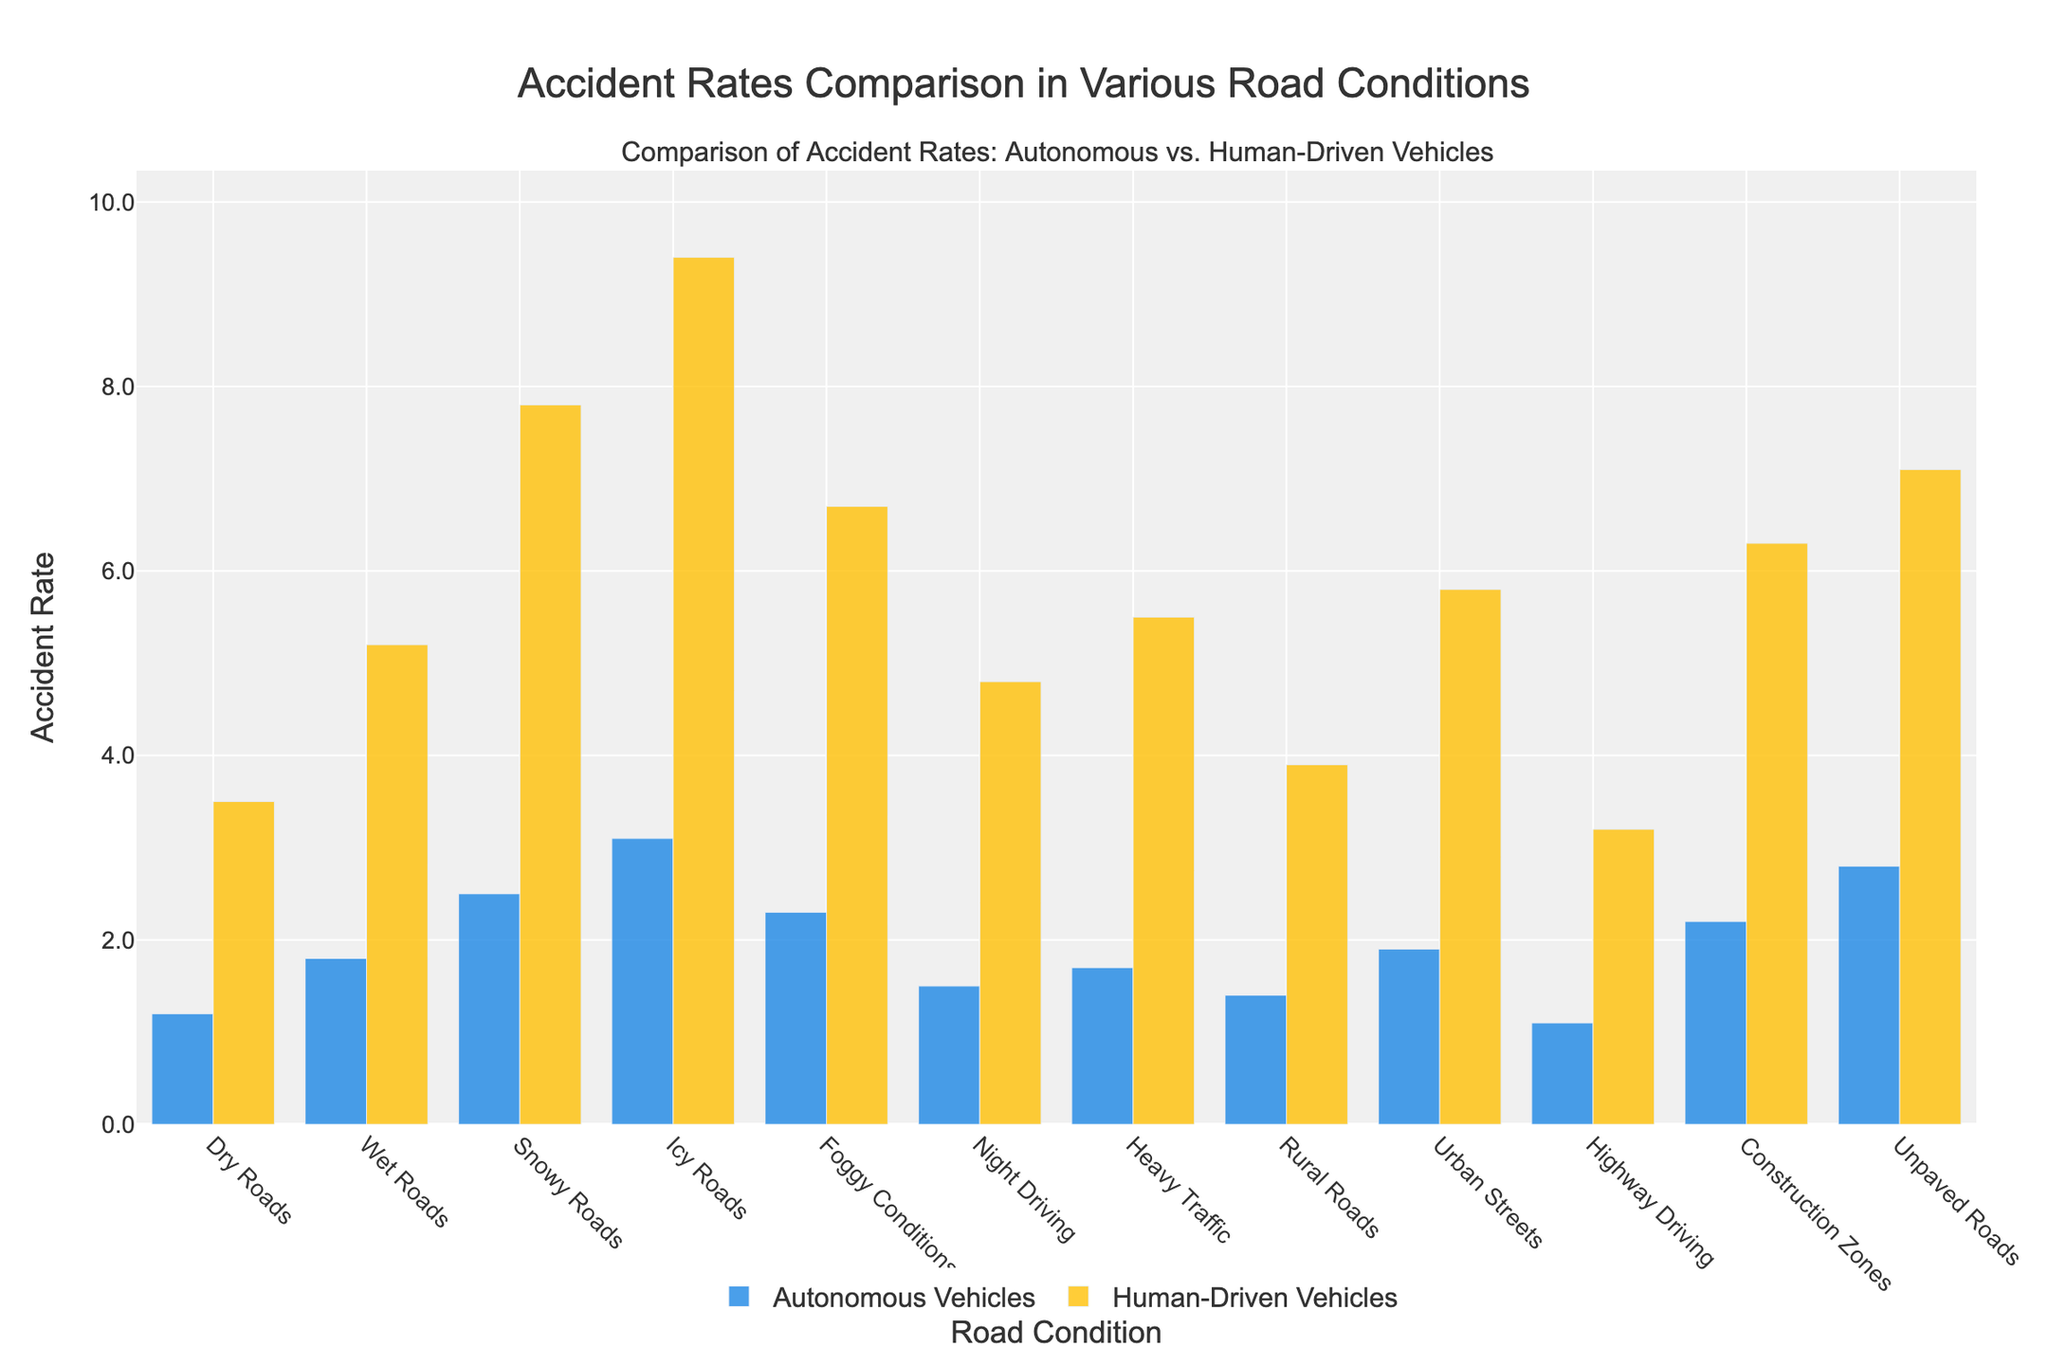What's the difference in accident rates on icy roads between autonomous and human-driven vehicles? The bars representing icy roads show that the accident rate for human-driven vehicles is 9.4, while for autonomous vehicles it is 3.1. Subtracting the autonomous rate from the human-driven rate gives 9.4 - 3.1 = 6.3.
Answer: 6.3 Which road condition has the smallest accident rate for autonomous vehicles? By comparing the heights of the blue bars representing autonomous vehicles across different road conditions, the highway driving condition shows the smallest accident rate of 1.1.
Answer: Highway Driving On which road condition is the difference in accident rates between autonomous and human-driven vehicles the greatest? The comparison of the difference between the yellow and blue bars across all conditions shows the largest difference on icy roads, calculated as 9.4 (human-driven) - 3.1 (autonomous) = 6.3.
Answer: Icy Roads What is the average accident rate for human-driven vehicles in all road conditions? Sum up the accident rates for human-driven vehicles across all road conditions: 3.5 + 5.2 + 7.8 + 9.4 + 6.7 + 4.8 + 5.5 + 3.9 + 5.8 + 3.2 + 6.3 + 7.1 = 69.2. The number of conditions is 12. The average rate is 69.2 / 12 = 5.77.
Answer: 5.77 How many road conditions have a lower accident rate for autonomous vehicles compared to human-driven vehicles? By visually inspecting the bars, all conditions show that the blue bar (autonomous vehicles) is lower than the yellow bar (human-driven vehicles). Therefore, the count is 12.
Answer: 12 What is the ratio of accident rates for human-driven to autonomous vehicles on wet roads? The accident rate on wet roads is 5.2 for human-driven and 1.8 for autonomous vehicles. The ratio is 5.2 / 1.8.
Answer: 2.89 Which road condition has the highest accident rate for autonomous vehicles? The tallest blue bar representing autonomous vehicles is observed in icy roads, with an accident rate of 3.1.
Answer: Icy Roads Are there any road conditions where the accident rate for human-driven vehicles is exactly three times that of autonomous vehicles? Reviewing the data, no condition shows the human-driven accident rate as exactly three times the autonomous accident rate.
Answer: No 